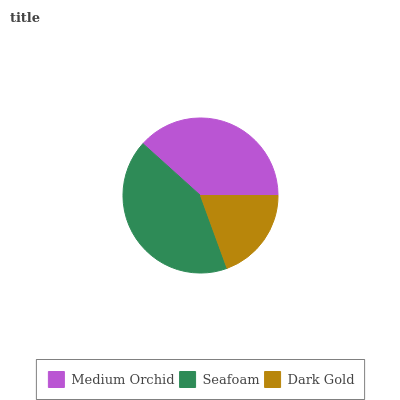Is Dark Gold the minimum?
Answer yes or no. Yes. Is Seafoam the maximum?
Answer yes or no. Yes. Is Seafoam the minimum?
Answer yes or no. No. Is Dark Gold the maximum?
Answer yes or no. No. Is Seafoam greater than Dark Gold?
Answer yes or no. Yes. Is Dark Gold less than Seafoam?
Answer yes or no. Yes. Is Dark Gold greater than Seafoam?
Answer yes or no. No. Is Seafoam less than Dark Gold?
Answer yes or no. No. Is Medium Orchid the high median?
Answer yes or no. Yes. Is Medium Orchid the low median?
Answer yes or no. Yes. Is Dark Gold the high median?
Answer yes or no. No. Is Dark Gold the low median?
Answer yes or no. No. 